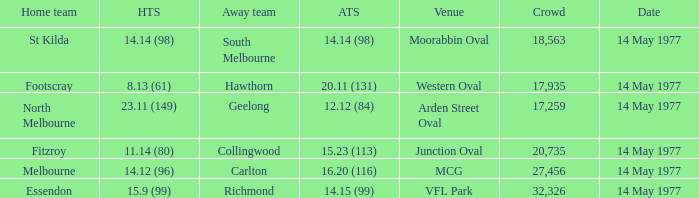I want to know the home team score of the away team of richmond that has a crowd more than 20,735 15.9 (99). 